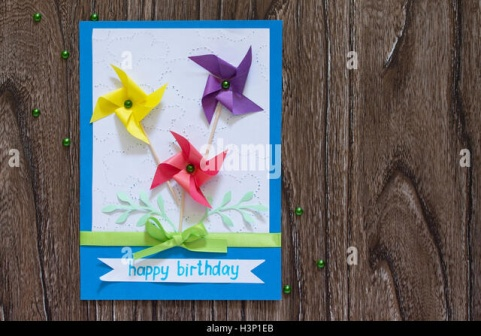Create a short playful interaction where the card seems to have a story of its own. Human: This card looks pretty special. I wonder if it has a story to tell.

GPT: Oh, it certainly does! Once, in a peaceful little craft room, I was brought to life by a pair of loving hands. The chirping of bird songs and the hum of creativity filled the air. These vibrant pinwheels were inspired by the joyous festivals of spring, each one representing a cherished moment of smiles and laughter. The green foliage whispers tales of nature walks and sunny picnics, while the ribbon remembers the gentle touch and thoughtful wishes of its maker. And as the handwriting danced across me, I felt imbued with a heartfelt wish for happiness, bound to bring cheer to the special person who receives me! 